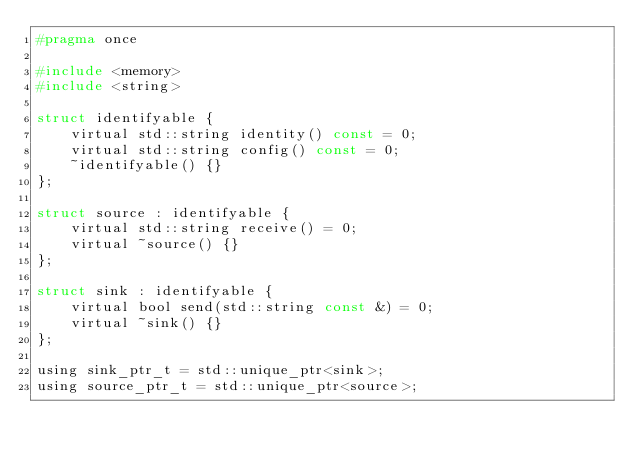Convert code to text. <code><loc_0><loc_0><loc_500><loc_500><_C_>#pragma once

#include <memory>
#include <string>

struct identifyable {
    virtual std::string identity() const = 0;
    virtual std::string config() const = 0;
    ~identifyable() {}
};

struct source : identifyable {
    virtual std::string receive() = 0;
    virtual ~source() {}
};

struct sink : identifyable {
    virtual bool send(std::string const &) = 0;
    virtual ~sink() {}
};

using sink_ptr_t = std::unique_ptr<sink>;
using source_ptr_t = std::unique_ptr<source>;
</code> 